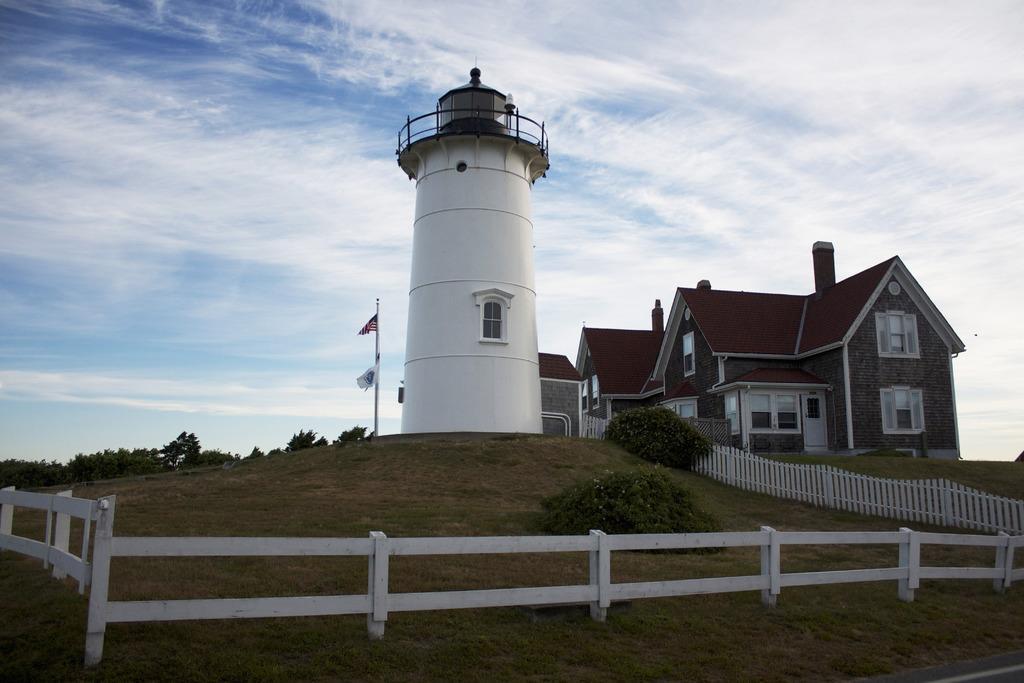Please provide a concise description of this image. In the image there are few houses and a tower and there is a flag beside the tower, the area around the houses and the tower is filled with grass and some plants and there is a white fencing around the grass. 